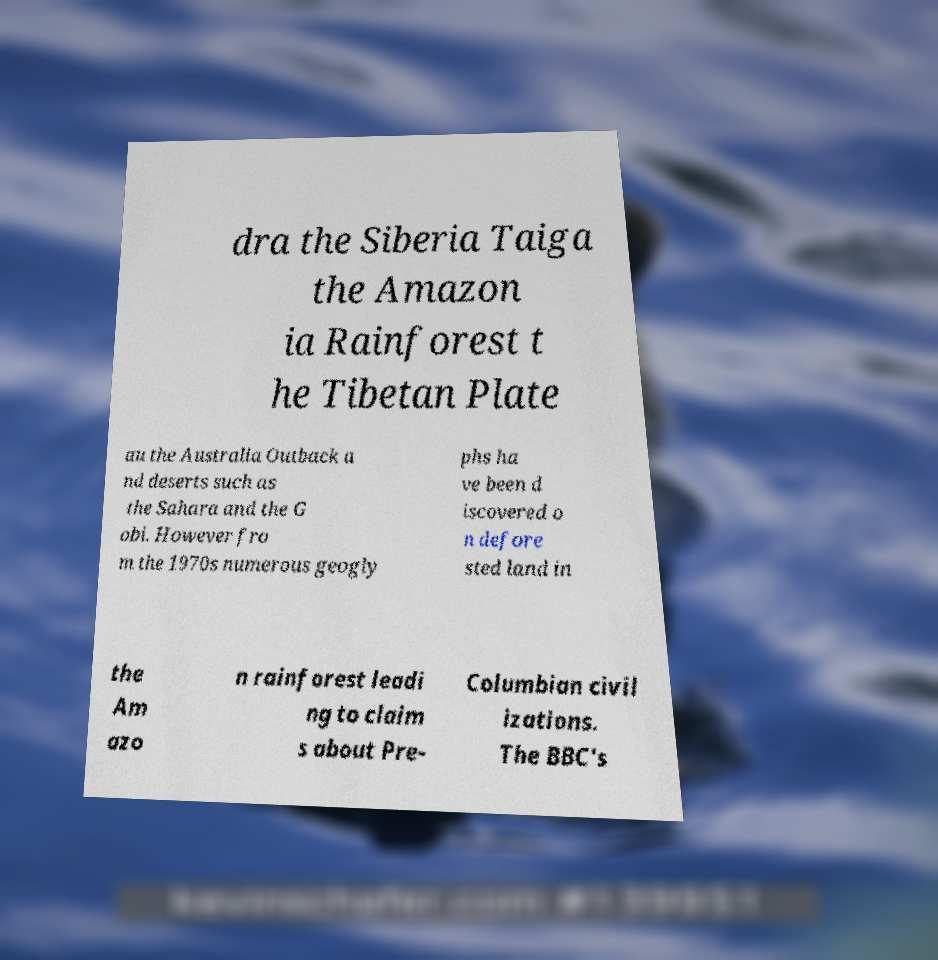Please read and relay the text visible in this image. What does it say? dra the Siberia Taiga the Amazon ia Rainforest t he Tibetan Plate au the Australia Outback a nd deserts such as the Sahara and the G obi. However fro m the 1970s numerous geogly phs ha ve been d iscovered o n defore sted land in the Am azo n rainforest leadi ng to claim s about Pre- Columbian civil izations. The BBC's 